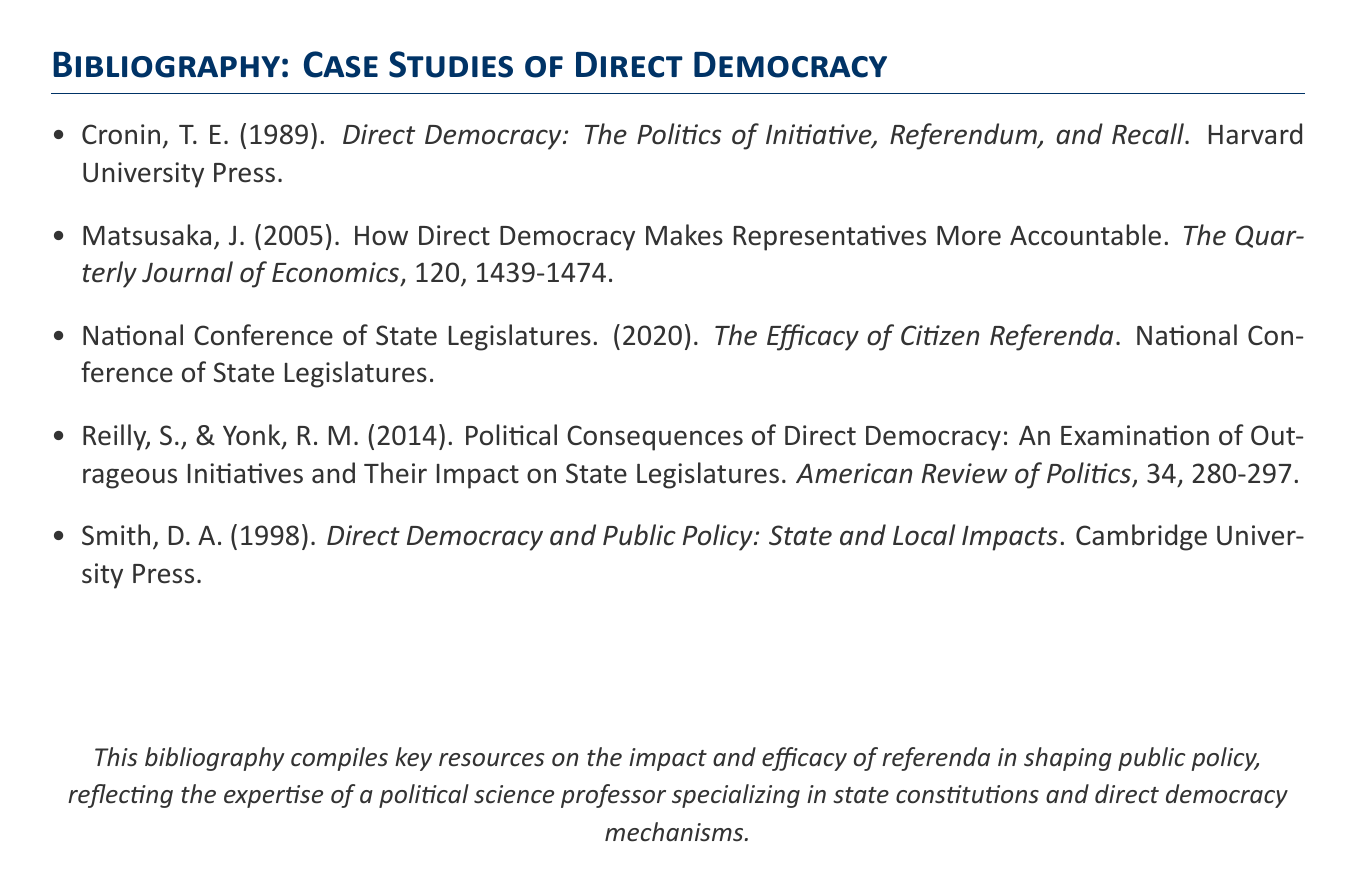What is the title of T. E. Cronin's book? The title of T. E. Cronin's book is directly mentioned in the bibliography section.
Answer: Direct Democracy: The Politics of Initiative, Referendum, and Recall Who are the authors of the article on the political consequences of direct democracy? The names of the authors are listed at the beginning of the citation for the article.
Answer: S. Reilly and R. M. Yonk In what year was the "Efficacy of Citizen Referenda" published? The publication year is cited for the National Conference of State Legislatures’ resource in the bibliography.
Answer: 2020 Which publication discusses how direct democracy affects the accountability of representatives? The relevant publication is specifically noted in the bibliography and highlights its focus on accountability.
Answer: The Quarterly Journal of Economics How many items are listed in the bibliography? The total number of bibliography entries can be counted from the provided list.
Answer: 5 What is the main subject of Smith's book according to the bibliography? The subject is indicated in the title of Smith's book, relating to public policy impacts.
Answer: Direct Democracy and Public Policy What is the publishing company for T. E. Cronin's book? The publication company is mentioned after the author's name and title in the citation.
Answer: Harvard University Press Which year was Matsusaka's article published? The publication year is clearly stated in the citation for the mentioned article.
Answer: 2005 What is the focus of the National Conference of State Legislatures' resource? The focus is derived from the title of the resource in the bibliography.
Answer: The Efficacy of Citizen Referenda 